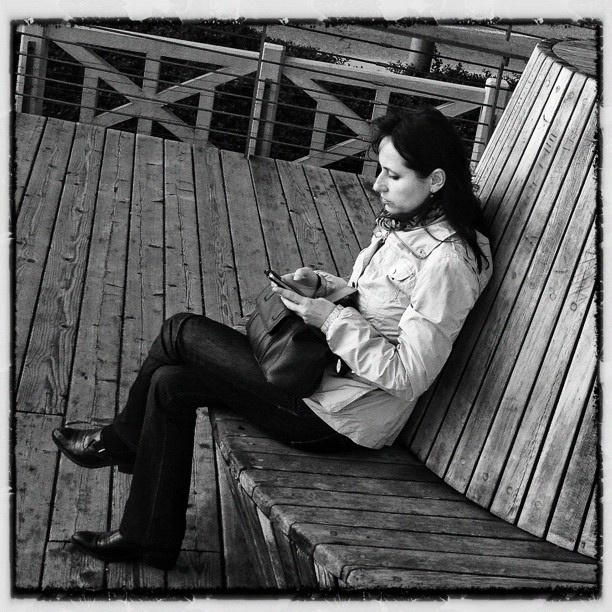Describe the objects in this image and their specific colors. I can see bench in lightgray, gray, black, and darkgray tones, people in lightgray, black, gray, and darkgray tones, handbag in lightgray, black, and gray tones, and cell phone in lightgray, black, gray, and white tones in this image. 